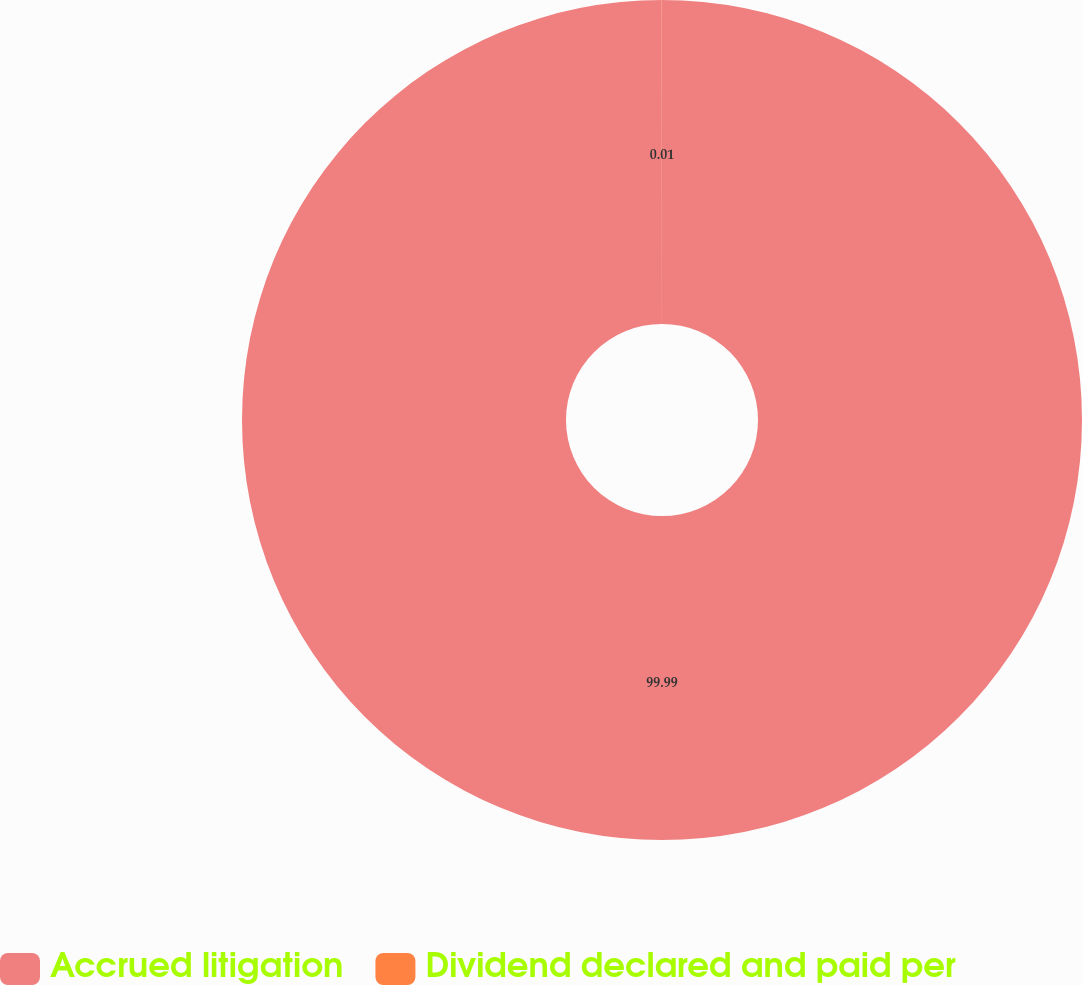<chart> <loc_0><loc_0><loc_500><loc_500><pie_chart><fcel>Accrued litigation<fcel>Dividend declared and paid per<nl><fcel>99.99%<fcel>0.01%<nl></chart> 